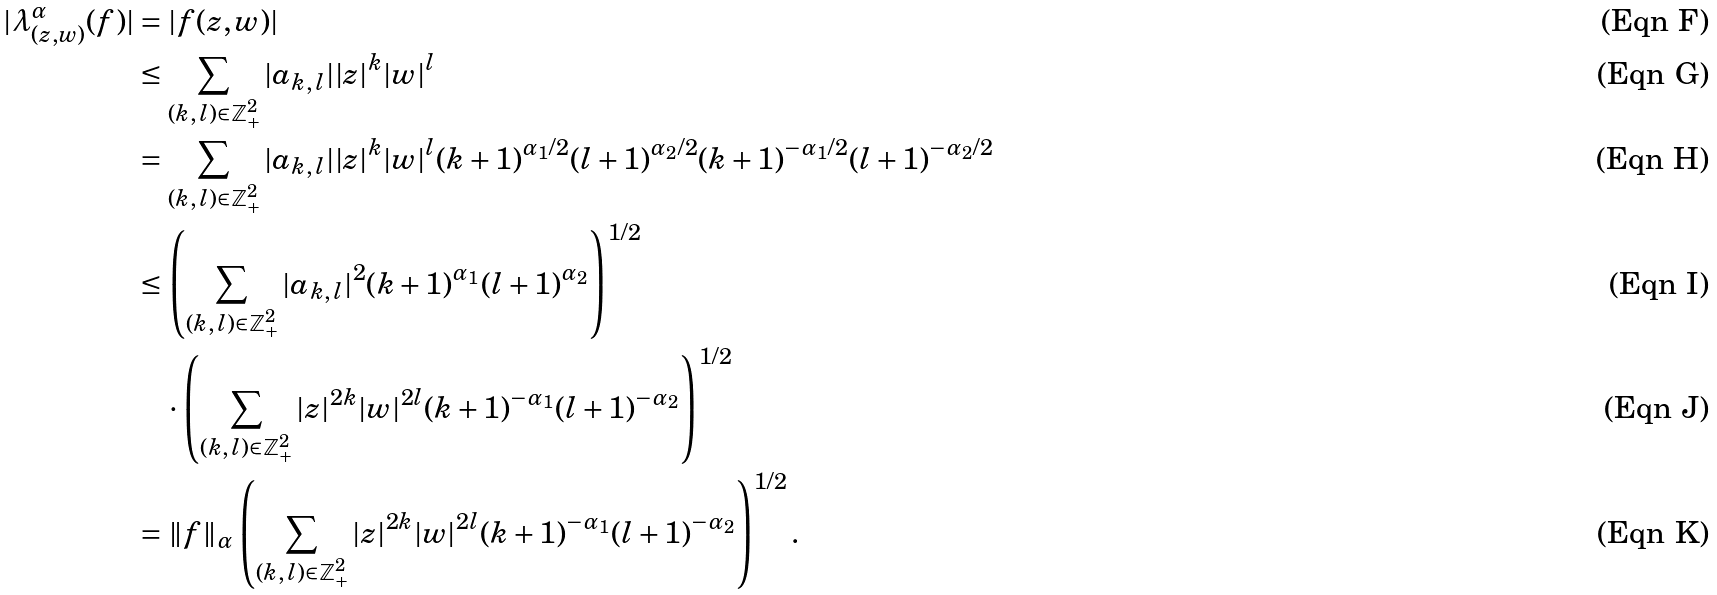<formula> <loc_0><loc_0><loc_500><loc_500>| \lambda _ { ( z , w ) } ^ { \alpha } ( f ) | & = | f ( z , w ) | \\ & \leq \sum _ { ( k , \, l ) \in \mathbb { Z } ^ { 2 } _ { + } } | a _ { k , \, l } | | z | ^ { k } | w | ^ { l } \\ & = \sum _ { ( k , \, l ) \in \mathbb { Z } ^ { 2 } _ { + } } | a _ { k , \, l } | | z | ^ { k } | w | ^ { l } ( k + 1 ) ^ { \alpha _ { 1 } / 2 } ( l + 1 ) ^ { \alpha _ { 2 } / 2 } ( k + 1 ) ^ { - \alpha _ { 1 } / 2 } ( l + 1 ) ^ { - \alpha _ { 2 } / 2 } \\ & \leq \left ( \sum _ { ( k , \, l ) \in \mathbb { Z } ^ { 2 } _ { + } } | a _ { k , \, l } | ^ { 2 } ( k + 1 ) ^ { \alpha _ { 1 } } ( l + 1 ) ^ { \alpha _ { 2 } } \right ) ^ { 1 / 2 } \\ & \quad \cdot \left ( \sum _ { ( k , \, l ) \in \mathbb { Z } ^ { 2 } _ { + } } | z | ^ { 2 k } | w | ^ { 2 l } ( k + 1 ) ^ { - \alpha _ { 1 } } ( l + 1 ) ^ { - \alpha _ { 2 } } \right ) ^ { 1 / 2 } \\ & = \| f \| _ { \alpha } \left ( \sum _ { ( k , \, l ) \in \mathbb { Z } ^ { 2 } _ { + } } | z | ^ { 2 k } | w | ^ { 2 l } ( k + 1 ) ^ { - \alpha _ { 1 } } ( l + 1 ) ^ { - \alpha _ { 2 } } \right ) ^ { 1 / 2 } .</formula> 